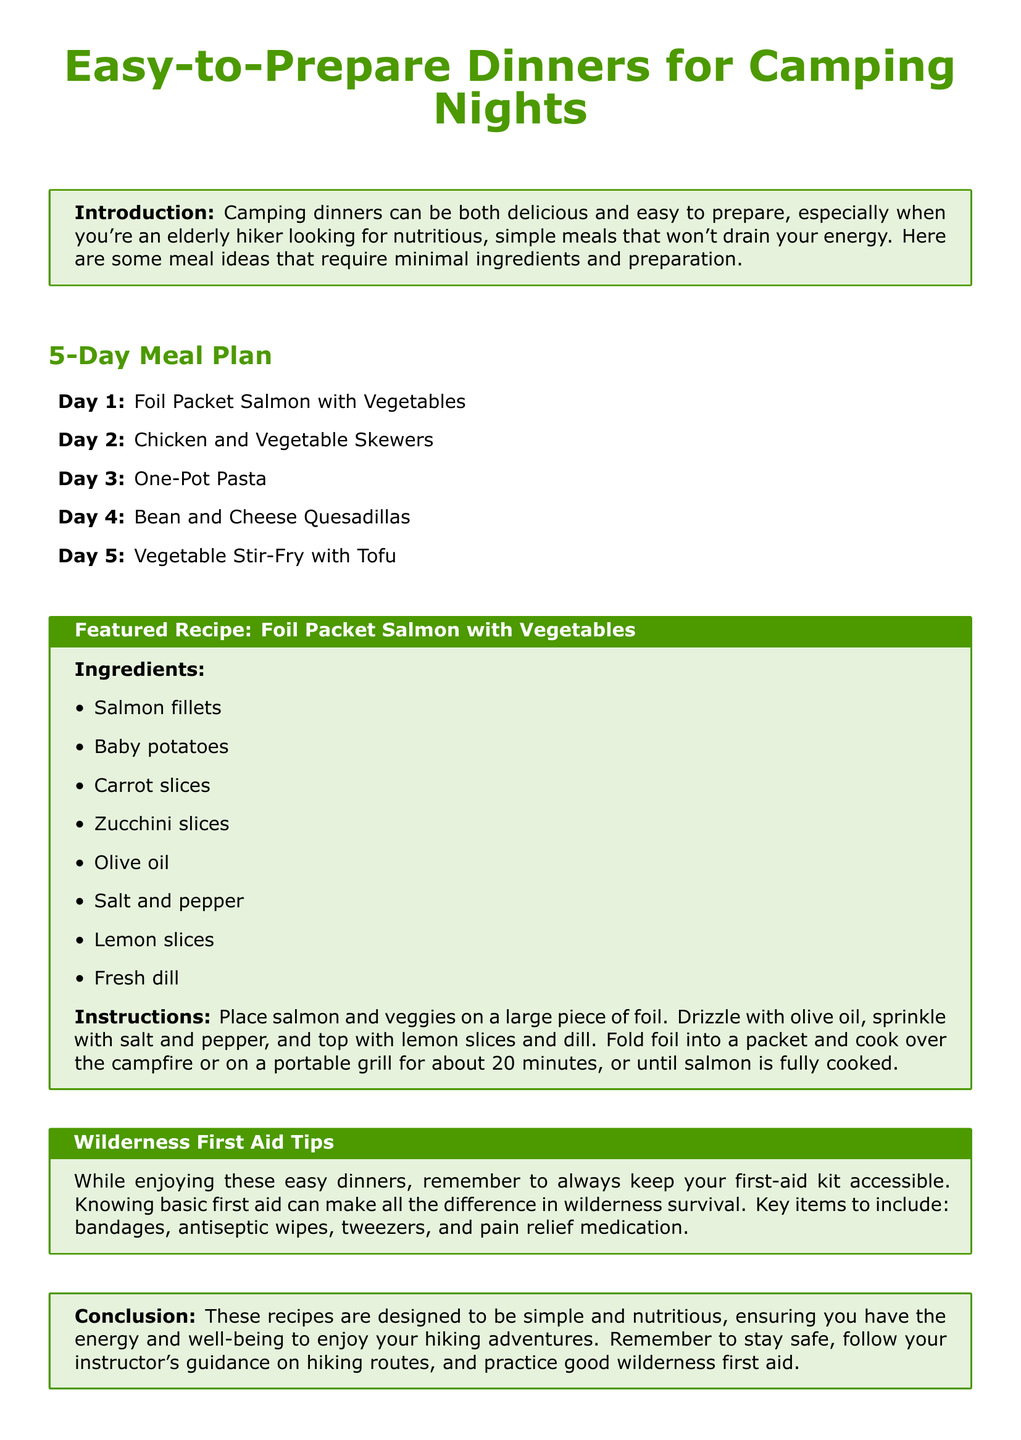What is the title of the meal plan? The title of the meal plan is prominently displayed at the top of the document.
Answer: Easy-to-Prepare Dinners for Camping Nights How many days does the meal plan cover? The document lists a meal for each of the five days in the plan.
Answer: 5 What is the featured recipe in the document? The document specifies the featured recipe in a dedicated recipe box.
Answer: Foil Packet Salmon with Vegetables What key items are recommended for a first-aid kit? The document provides a specific section with suggested items for wilderness first aid.
Answer: Bandages, antiseptic wipes, tweezers, pain relief medication What vegetable is used in the Foil Packet Salmon recipe? The recipe section lists the ingredients needed for the featured meal.
Answer: Zucchini slices What cooking method is suggested for the salmon? The document describes how to prepare the meal, including the cooking method.
Answer: Campfire or portable grill What is the conclusion's main focus? The conclusion summarizes the overall intent and message of the meal plan.
Answer: Simple and nutritious recipes 